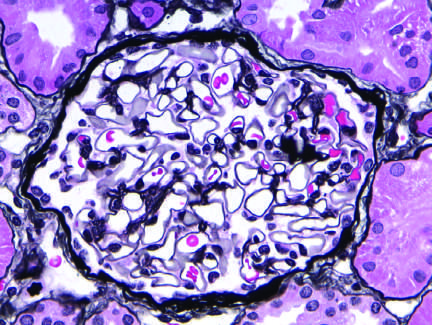does the silver methenamine-stained glomerulus appear normal, with a delicate basement membrane?
Answer the question using a single word or phrase. Yes 